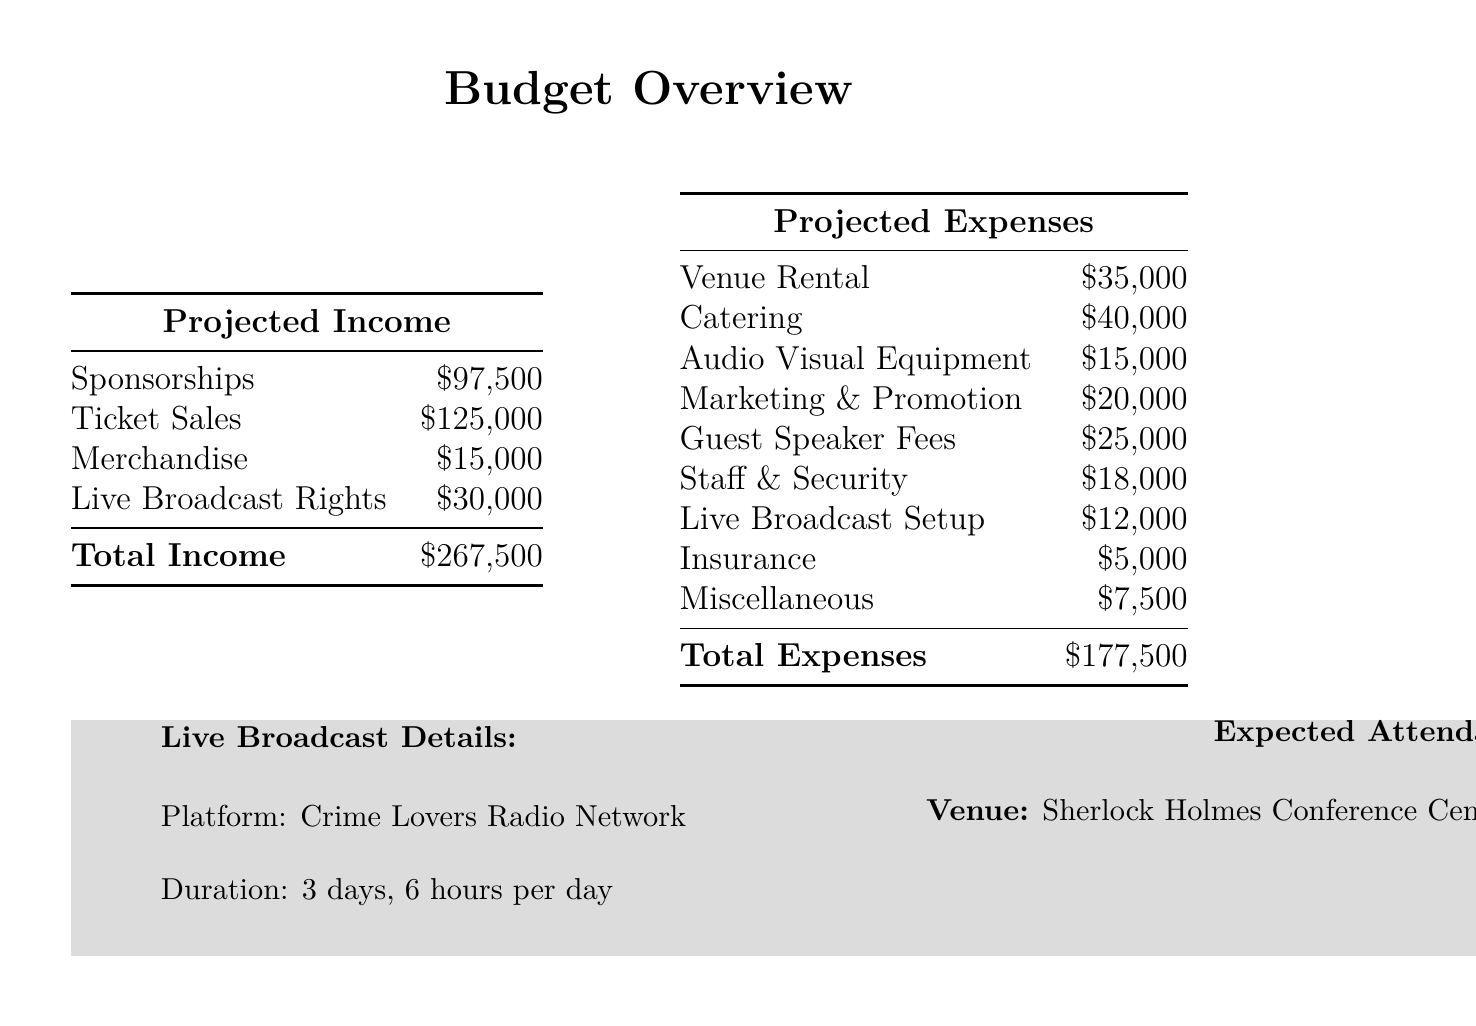What is the total projected income? The total projected income is the sum of all income sources in the document, which is $97,500 + $125,000 + $15,000 + $30,000 = $267,500.
Answer: $267,500 What are the projected expenses for catering? The projected expenses for catering are explicitly listed in the document as $40,000.
Answer: $40,000 What is the date range of the convention? The date range of the convention is stated in the document as October 15-17, 2023.
Answer: October 15-17, 2023 What is the expected attendance? The expected attendance of the event is mentioned in the document as 2,500.
Answer: 2,500 What is the projected net profit? The projected net profit is calculated in the document by subtracting total expenses from total income, which results in $267,500 - $177,500 = $90,000.
Answer: $90,000 Which platform will host the live broadcast? The platform that will host the live broadcast is indicated in the document as Crime Lovers Radio Network.
Answer: Crime Lovers Radio Network How much is allocated for guest speaker fees? The allocation for guest speaker fees is specified in the document as $25,000.
Answer: $25,000 What is the total cost for audio visual equipment? The total cost for audio visual equipment is directly stated in the document as $15,000.
Answer: $15,000 What venue will the convention take place in? The venue where the convention will take place is identified in the document as Sherlock Holmes Conference Center, London.
Answer: Sherlock Holmes Conference Center, London 